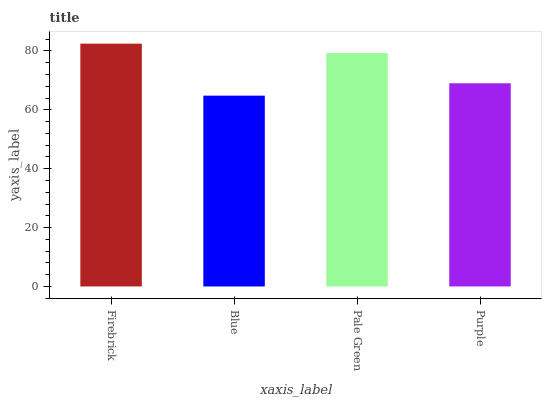Is Blue the minimum?
Answer yes or no. Yes. Is Firebrick the maximum?
Answer yes or no. Yes. Is Pale Green the minimum?
Answer yes or no. No. Is Pale Green the maximum?
Answer yes or no. No. Is Pale Green greater than Blue?
Answer yes or no. Yes. Is Blue less than Pale Green?
Answer yes or no. Yes. Is Blue greater than Pale Green?
Answer yes or no. No. Is Pale Green less than Blue?
Answer yes or no. No. Is Pale Green the high median?
Answer yes or no. Yes. Is Purple the low median?
Answer yes or no. Yes. Is Firebrick the high median?
Answer yes or no. No. Is Blue the low median?
Answer yes or no. No. 